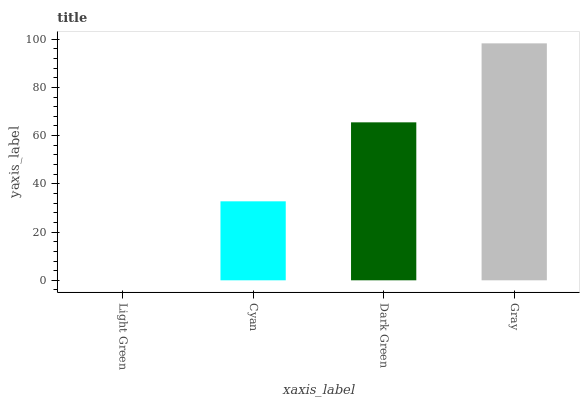Is Light Green the minimum?
Answer yes or no. Yes. Is Gray the maximum?
Answer yes or no. Yes. Is Cyan the minimum?
Answer yes or no. No. Is Cyan the maximum?
Answer yes or no. No. Is Cyan greater than Light Green?
Answer yes or no. Yes. Is Light Green less than Cyan?
Answer yes or no. Yes. Is Light Green greater than Cyan?
Answer yes or no. No. Is Cyan less than Light Green?
Answer yes or no. No. Is Dark Green the high median?
Answer yes or no. Yes. Is Cyan the low median?
Answer yes or no. Yes. Is Cyan the high median?
Answer yes or no. No. Is Dark Green the low median?
Answer yes or no. No. 